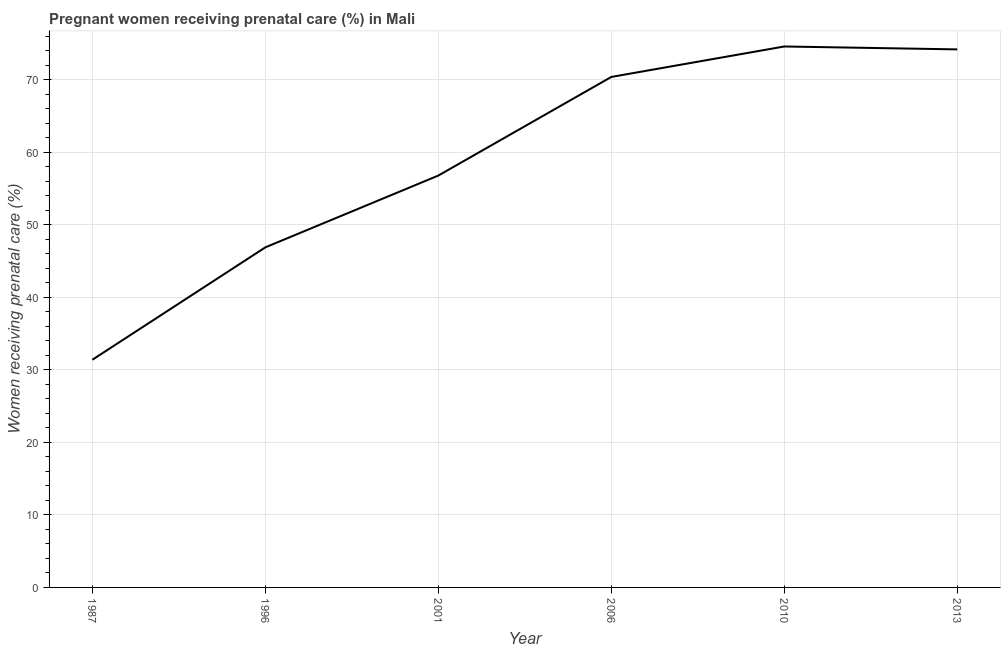What is the percentage of pregnant women receiving prenatal care in 2013?
Ensure brevity in your answer.  74.2. Across all years, what is the maximum percentage of pregnant women receiving prenatal care?
Ensure brevity in your answer.  74.6. Across all years, what is the minimum percentage of pregnant women receiving prenatal care?
Offer a terse response. 31.4. In which year was the percentage of pregnant women receiving prenatal care maximum?
Offer a terse response. 2010. In which year was the percentage of pregnant women receiving prenatal care minimum?
Offer a terse response. 1987. What is the sum of the percentage of pregnant women receiving prenatal care?
Your answer should be compact. 354.3. What is the difference between the percentage of pregnant women receiving prenatal care in 1996 and 2013?
Keep it short and to the point. -27.3. What is the average percentage of pregnant women receiving prenatal care per year?
Your response must be concise. 59.05. What is the median percentage of pregnant women receiving prenatal care?
Your answer should be compact. 63.6. In how many years, is the percentage of pregnant women receiving prenatal care greater than 72 %?
Make the answer very short. 2. What is the ratio of the percentage of pregnant women receiving prenatal care in 1996 to that in 2013?
Offer a very short reply. 0.63. What is the difference between the highest and the second highest percentage of pregnant women receiving prenatal care?
Keep it short and to the point. 0.4. Is the sum of the percentage of pregnant women receiving prenatal care in 2006 and 2010 greater than the maximum percentage of pregnant women receiving prenatal care across all years?
Keep it short and to the point. Yes. What is the difference between the highest and the lowest percentage of pregnant women receiving prenatal care?
Offer a terse response. 43.2. How many years are there in the graph?
Your response must be concise. 6. What is the difference between two consecutive major ticks on the Y-axis?
Provide a succinct answer. 10. Are the values on the major ticks of Y-axis written in scientific E-notation?
Your response must be concise. No. Does the graph contain any zero values?
Your response must be concise. No. What is the title of the graph?
Give a very brief answer. Pregnant women receiving prenatal care (%) in Mali. What is the label or title of the X-axis?
Offer a very short reply. Year. What is the label or title of the Y-axis?
Your answer should be compact. Women receiving prenatal care (%). What is the Women receiving prenatal care (%) in 1987?
Make the answer very short. 31.4. What is the Women receiving prenatal care (%) of 1996?
Offer a terse response. 46.9. What is the Women receiving prenatal care (%) in 2001?
Offer a very short reply. 56.8. What is the Women receiving prenatal care (%) of 2006?
Ensure brevity in your answer.  70.4. What is the Women receiving prenatal care (%) in 2010?
Your response must be concise. 74.6. What is the Women receiving prenatal care (%) in 2013?
Ensure brevity in your answer.  74.2. What is the difference between the Women receiving prenatal care (%) in 1987 and 1996?
Your answer should be very brief. -15.5. What is the difference between the Women receiving prenatal care (%) in 1987 and 2001?
Your answer should be compact. -25.4. What is the difference between the Women receiving prenatal care (%) in 1987 and 2006?
Provide a short and direct response. -39. What is the difference between the Women receiving prenatal care (%) in 1987 and 2010?
Your answer should be very brief. -43.2. What is the difference between the Women receiving prenatal care (%) in 1987 and 2013?
Provide a short and direct response. -42.8. What is the difference between the Women receiving prenatal care (%) in 1996 and 2001?
Your answer should be compact. -9.9. What is the difference between the Women receiving prenatal care (%) in 1996 and 2006?
Provide a short and direct response. -23.5. What is the difference between the Women receiving prenatal care (%) in 1996 and 2010?
Offer a terse response. -27.7. What is the difference between the Women receiving prenatal care (%) in 1996 and 2013?
Offer a very short reply. -27.3. What is the difference between the Women receiving prenatal care (%) in 2001 and 2010?
Your response must be concise. -17.8. What is the difference between the Women receiving prenatal care (%) in 2001 and 2013?
Give a very brief answer. -17.4. What is the difference between the Women receiving prenatal care (%) in 2006 and 2010?
Offer a very short reply. -4.2. What is the difference between the Women receiving prenatal care (%) in 2006 and 2013?
Your answer should be very brief. -3.8. What is the difference between the Women receiving prenatal care (%) in 2010 and 2013?
Keep it short and to the point. 0.4. What is the ratio of the Women receiving prenatal care (%) in 1987 to that in 1996?
Offer a very short reply. 0.67. What is the ratio of the Women receiving prenatal care (%) in 1987 to that in 2001?
Your answer should be very brief. 0.55. What is the ratio of the Women receiving prenatal care (%) in 1987 to that in 2006?
Provide a succinct answer. 0.45. What is the ratio of the Women receiving prenatal care (%) in 1987 to that in 2010?
Provide a short and direct response. 0.42. What is the ratio of the Women receiving prenatal care (%) in 1987 to that in 2013?
Keep it short and to the point. 0.42. What is the ratio of the Women receiving prenatal care (%) in 1996 to that in 2001?
Offer a very short reply. 0.83. What is the ratio of the Women receiving prenatal care (%) in 1996 to that in 2006?
Your answer should be compact. 0.67. What is the ratio of the Women receiving prenatal care (%) in 1996 to that in 2010?
Provide a short and direct response. 0.63. What is the ratio of the Women receiving prenatal care (%) in 1996 to that in 2013?
Keep it short and to the point. 0.63. What is the ratio of the Women receiving prenatal care (%) in 2001 to that in 2006?
Keep it short and to the point. 0.81. What is the ratio of the Women receiving prenatal care (%) in 2001 to that in 2010?
Your answer should be compact. 0.76. What is the ratio of the Women receiving prenatal care (%) in 2001 to that in 2013?
Your answer should be very brief. 0.77. What is the ratio of the Women receiving prenatal care (%) in 2006 to that in 2010?
Provide a succinct answer. 0.94. What is the ratio of the Women receiving prenatal care (%) in 2006 to that in 2013?
Offer a terse response. 0.95. What is the ratio of the Women receiving prenatal care (%) in 2010 to that in 2013?
Provide a short and direct response. 1. 